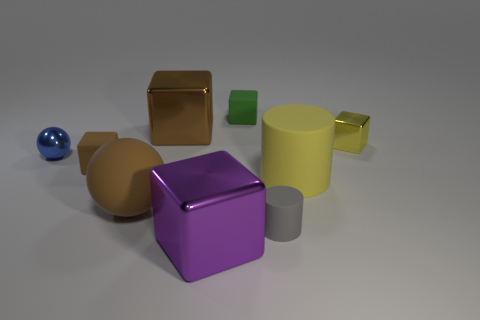Is the material of the large brown object behind the big yellow rubber thing the same as the small yellow object?
Provide a succinct answer. Yes. What material is the big cube right of the brown cube that is behind the small shiny object to the left of the big purple block?
Your answer should be very brief. Metal. How many other things are the same shape as the small yellow thing?
Provide a short and direct response. 4. The large metallic thing on the left side of the purple metal object is what color?
Keep it short and to the point. Brown. How many tiny brown matte blocks are in front of the matte block that is behind the yellow thing behind the blue thing?
Make the answer very short. 1. There is a small matte block that is behind the tiny brown rubber cube; what number of matte cubes are on the left side of it?
Provide a short and direct response. 1. There is a big purple cube; how many large rubber cylinders are behind it?
Offer a terse response. 1. What number of other objects are there of the same size as the yellow block?
Your response must be concise. 4. There is a purple metallic thing that is the same shape as the green rubber thing; what is its size?
Provide a succinct answer. Large. What shape is the yellow object that is behind the big matte cylinder?
Ensure brevity in your answer.  Cube. 